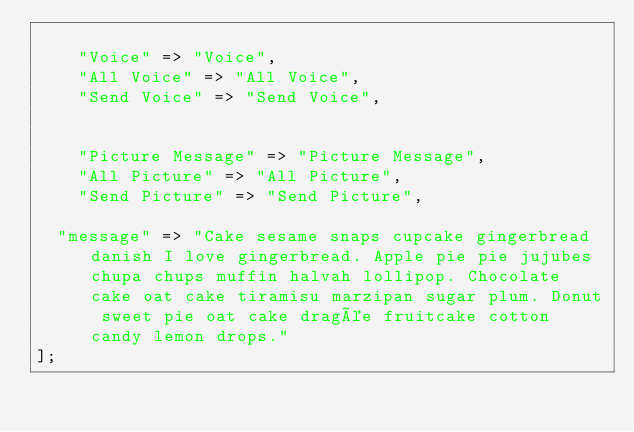Convert code to text. <code><loc_0><loc_0><loc_500><loc_500><_PHP_>
    "Voice" => "Voice",
    "All Voice" => "All Voice",
    "Send Voice" => "Send Voice",


    "Picture Message" => "Picture Message",
    "All Picture" => "All Picture",
    "Send Picture" => "Send Picture",

  "message" => "Cake sesame snaps cupcake gingerbread danish I love gingerbread. Apple pie pie jujubes chupa chups muffin halvah lollipop. Chocolate cake oat cake tiramisu marzipan sugar plum. Donut sweet pie oat cake dragée fruitcake cotton candy lemon drops."
];
</code> 